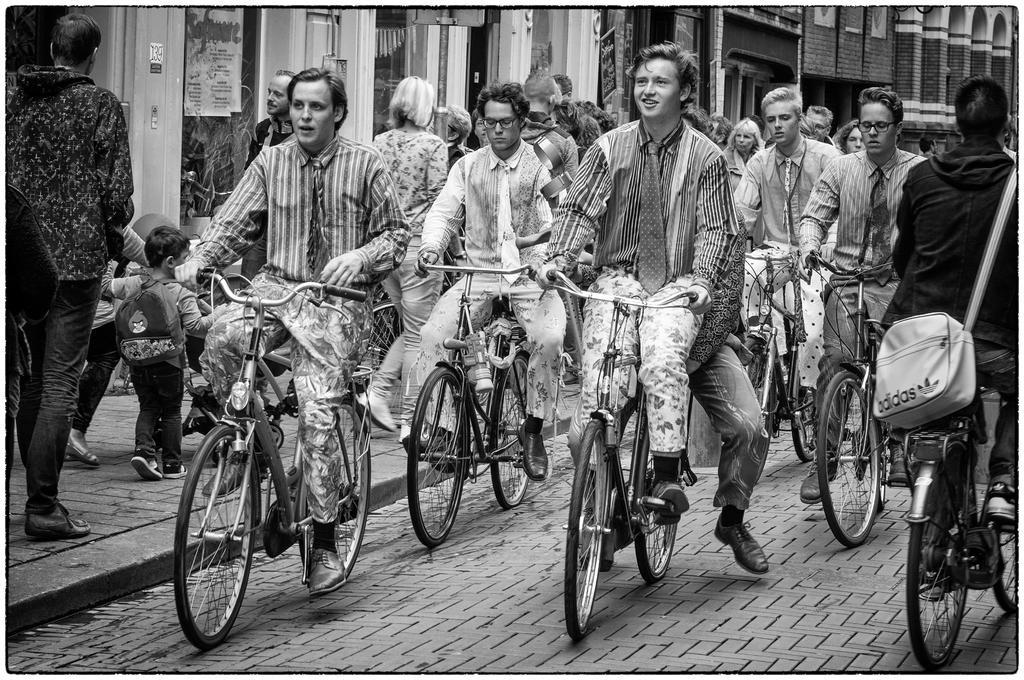Can you describe this image briefly? In this picture there are a group of people riding a bicycle on the road and they are people walking on the walk way. 